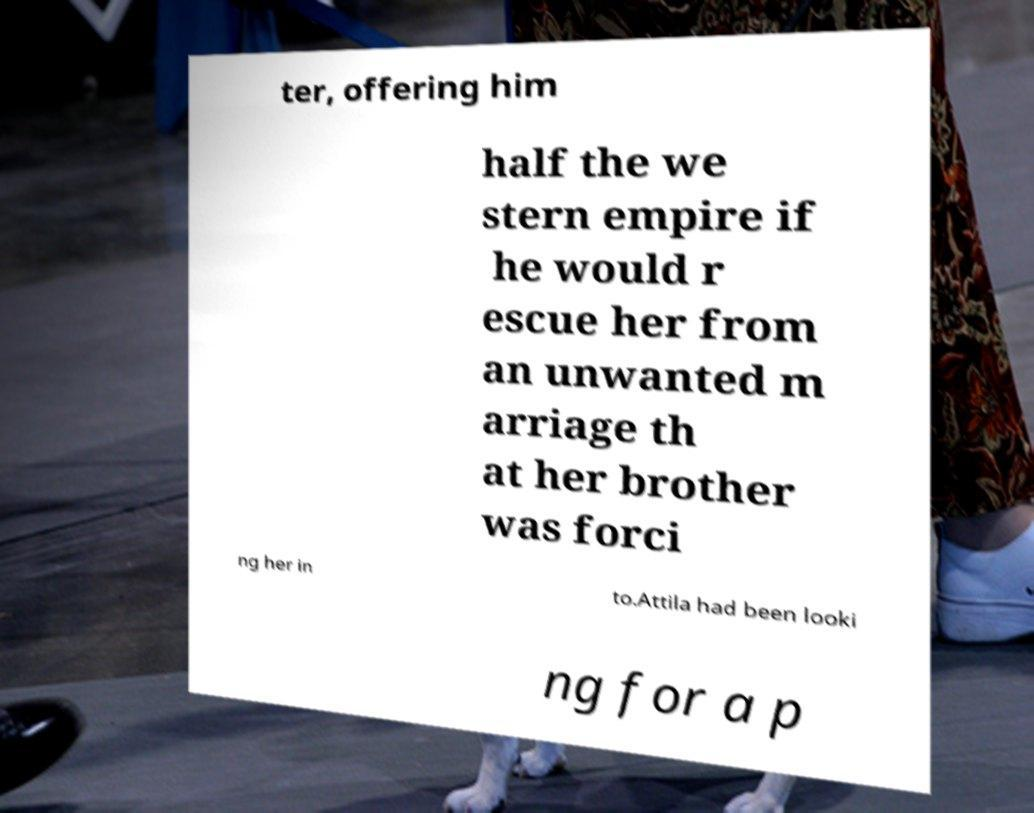What messages or text are displayed in this image? I need them in a readable, typed format. ter, offering him half the we stern empire if he would r escue her from an unwanted m arriage th at her brother was forci ng her in to.Attila had been looki ng for a p 